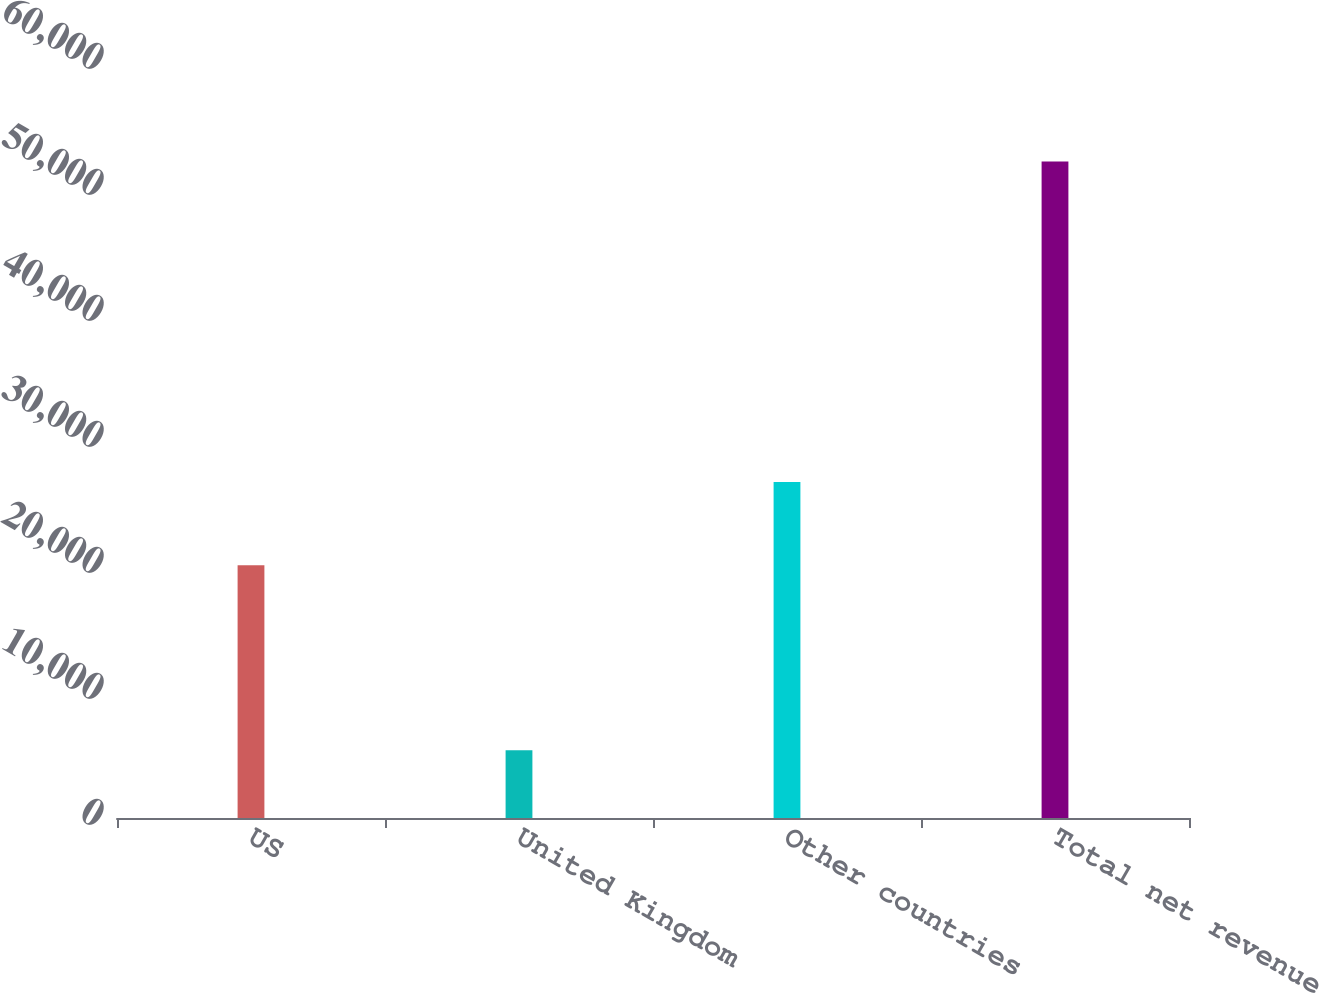<chart> <loc_0><loc_0><loc_500><loc_500><bar_chart><fcel>US<fcel>United Kingdom<fcel>Other countries<fcel>Total net revenue<nl><fcel>20063<fcel>5379<fcel>26665<fcel>52107<nl></chart> 